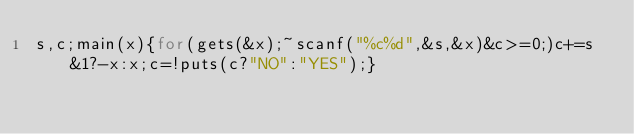Convert code to text. <code><loc_0><loc_0><loc_500><loc_500><_C_>s,c;main(x){for(gets(&x);~scanf("%c%d",&s,&x)&c>=0;)c+=s&1?-x:x;c=!puts(c?"NO":"YES");}</code> 